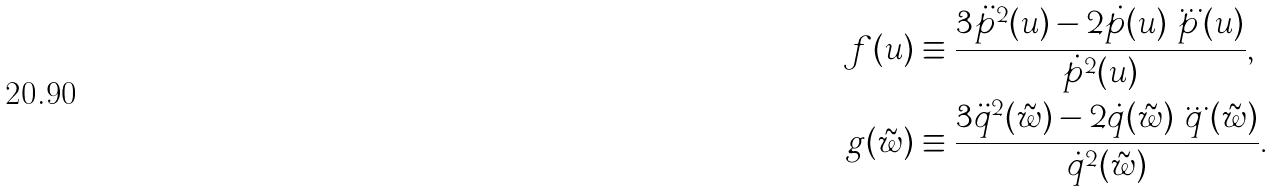Convert formula to latex. <formula><loc_0><loc_0><loc_500><loc_500>f ( u ) & \equiv \frac { 3 \ddot { p } ^ { 2 } ( u ) - 2 \dot { p } ( u ) \, \dddot { p } ( u ) } { \dot { p } ^ { 2 } ( u ) } , \\ g ( \tilde { w } ) & \equiv \frac { 3 \ddot { q } ^ { 2 } ( \tilde { w } ) - 2 \dot { q } ( \tilde { w } ) \, \dddot { q } ( \tilde { w } ) } { \dot { q } ^ { 2 } ( \tilde { w } ) } .</formula> 